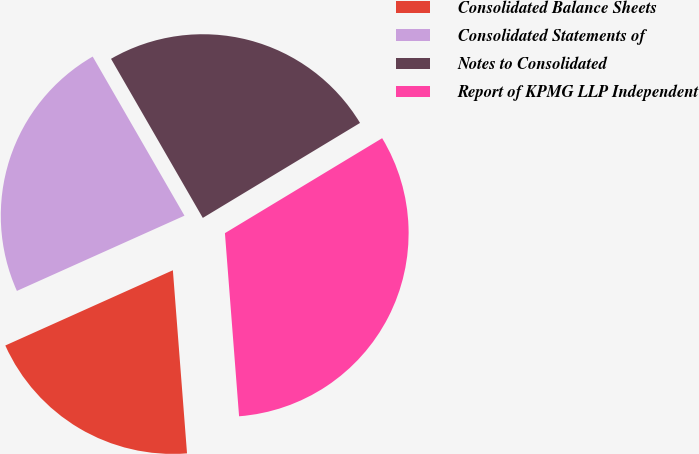Convert chart to OTSL. <chart><loc_0><loc_0><loc_500><loc_500><pie_chart><fcel>Consolidated Balance Sheets<fcel>Consolidated Statements of<fcel>Notes to Consolidated<fcel>Report of KPMG LLP Independent<nl><fcel>19.51%<fcel>23.39%<fcel>24.68%<fcel>32.42%<nl></chart> 